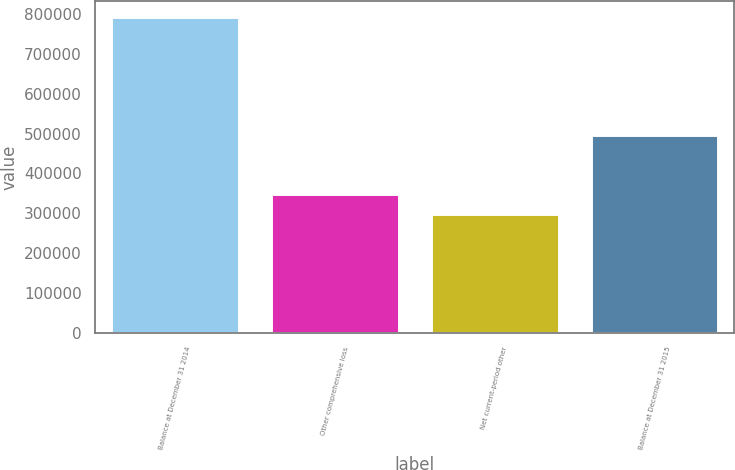<chart> <loc_0><loc_0><loc_500><loc_500><bar_chart><fcel>Balance at December 31 2014<fcel>Other comprehensive loss<fcel>Net current-period other<fcel>Balance at December 31 2015<nl><fcel>793082<fcel>347183<fcel>297639<fcel>495443<nl></chart> 